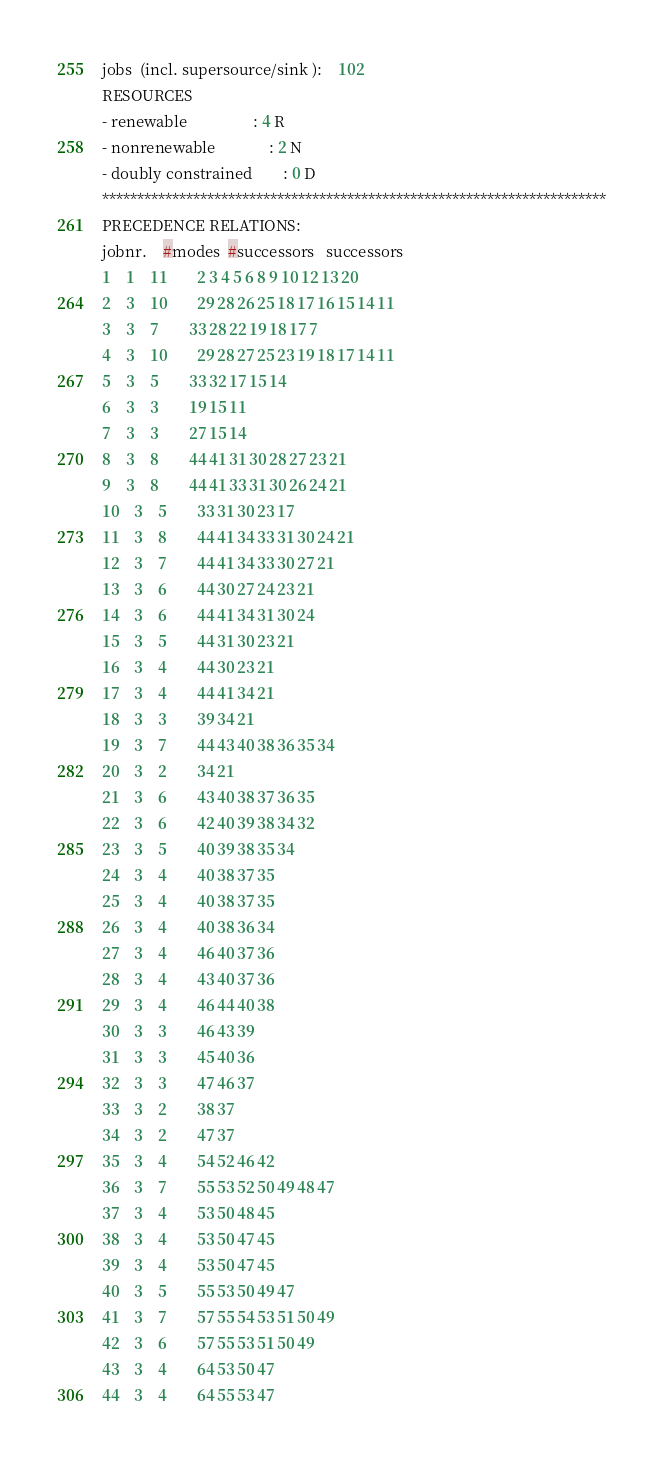<code> <loc_0><loc_0><loc_500><loc_500><_ObjectiveC_>jobs  (incl. supersource/sink ):	102
RESOURCES
- renewable                 : 4 R
- nonrenewable              : 2 N
- doubly constrained        : 0 D
************************************************************************
PRECEDENCE RELATIONS:
jobnr.    #modes  #successors   successors
1	1	11		2 3 4 5 6 8 9 10 12 13 20 
2	3	10		29 28 26 25 18 17 16 15 14 11 
3	3	7		33 28 22 19 18 17 7 
4	3	10		29 28 27 25 23 19 18 17 14 11 
5	3	5		33 32 17 15 14 
6	3	3		19 15 11 
7	3	3		27 15 14 
8	3	8		44 41 31 30 28 27 23 21 
9	3	8		44 41 33 31 30 26 24 21 
10	3	5		33 31 30 23 17 
11	3	8		44 41 34 33 31 30 24 21 
12	3	7		44 41 34 33 30 27 21 
13	3	6		44 30 27 24 23 21 
14	3	6		44 41 34 31 30 24 
15	3	5		44 31 30 23 21 
16	3	4		44 30 23 21 
17	3	4		44 41 34 21 
18	3	3		39 34 21 
19	3	7		44 43 40 38 36 35 34 
20	3	2		34 21 
21	3	6		43 40 38 37 36 35 
22	3	6		42 40 39 38 34 32 
23	3	5		40 39 38 35 34 
24	3	4		40 38 37 35 
25	3	4		40 38 37 35 
26	3	4		40 38 36 34 
27	3	4		46 40 37 36 
28	3	4		43 40 37 36 
29	3	4		46 44 40 38 
30	3	3		46 43 39 
31	3	3		45 40 36 
32	3	3		47 46 37 
33	3	2		38 37 
34	3	2		47 37 
35	3	4		54 52 46 42 
36	3	7		55 53 52 50 49 48 47 
37	3	4		53 50 48 45 
38	3	4		53 50 47 45 
39	3	4		53 50 47 45 
40	3	5		55 53 50 49 47 
41	3	7		57 55 54 53 51 50 49 
42	3	6		57 55 53 51 50 49 
43	3	4		64 53 50 47 
44	3	4		64 55 53 47 </code> 